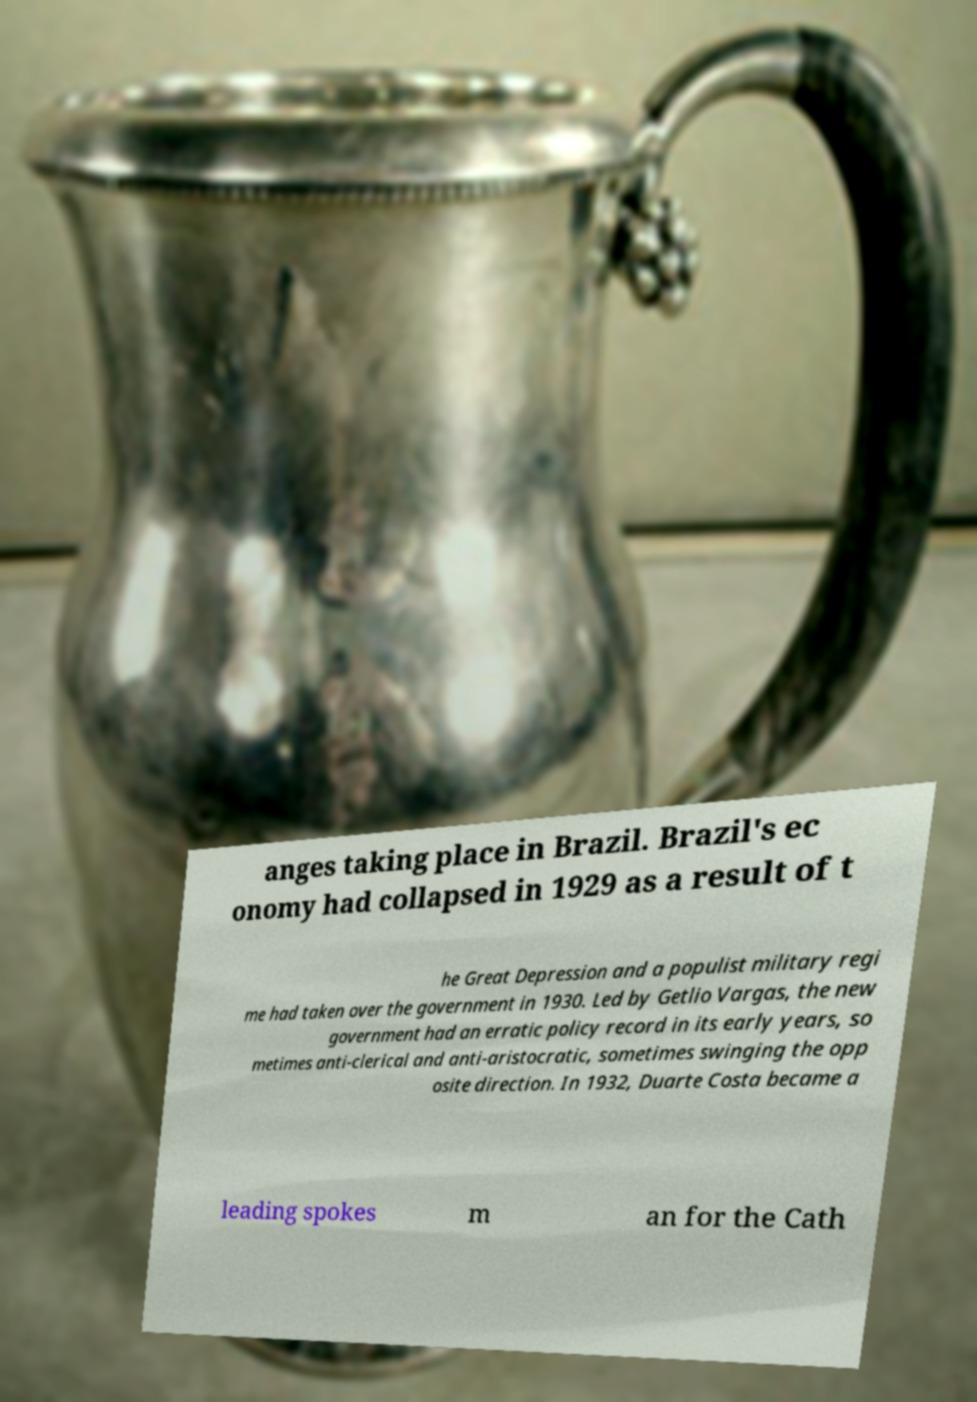I need the written content from this picture converted into text. Can you do that? anges taking place in Brazil. Brazil's ec onomy had collapsed in 1929 as a result of t he Great Depression and a populist military regi me had taken over the government in 1930. Led by Getlio Vargas, the new government had an erratic policy record in its early years, so metimes anti-clerical and anti-aristocratic, sometimes swinging the opp osite direction. In 1932, Duarte Costa became a leading spokes m an for the Cath 